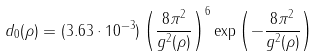Convert formula to latex. <formula><loc_0><loc_0><loc_500><loc_500>d _ { 0 } ( \rho ) = ( 3 . 6 3 \cdot 1 0 ^ { - 3 } ) \left ( \frac { 8 \pi ^ { 2 } } { g ^ { 2 } ( \rho ) } \right ) ^ { 6 } \exp { \left ( - \frac { 8 \pi ^ { 2 } } { g ^ { 2 } ( \rho ) } \right ) }</formula> 